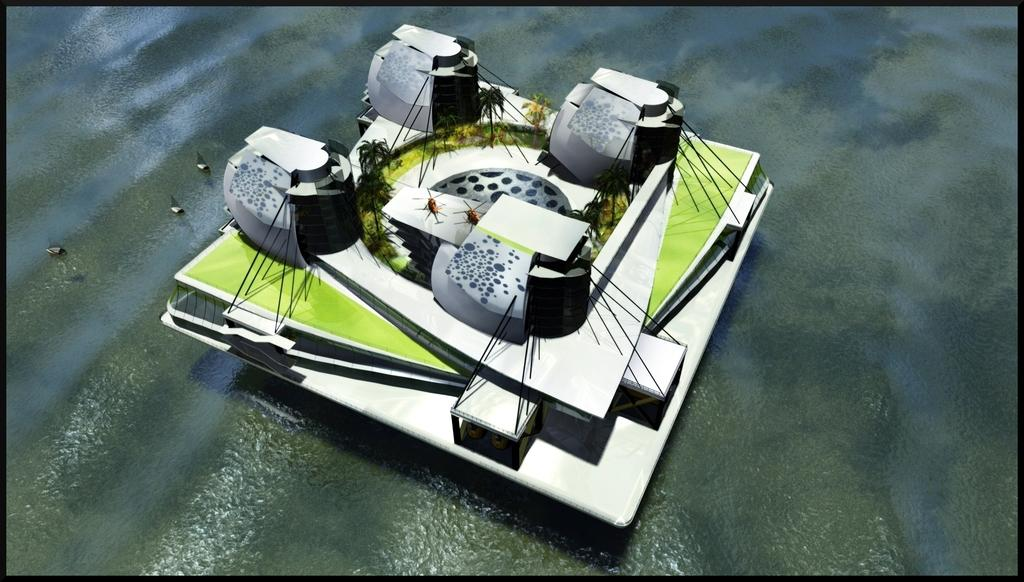What type of structure is present in the image? There is a building in the image. What natural elements can be seen in the image? There are trees in the image. What mode of transportation is depicted in the image? There are planes in the image. What body of water is visible in the image? There is water visible in the image. What other type of transportation can be seen in the image? There are boats in the image. What is the credit score of the person operating the boat in the image? There is no information about a person operating the boat or their credit score in the image. How does the acoustics of the building affect the sound of the planes in the image? The image does not provide any information about the acoustics of the building or how it might affect the sound of the planes. 